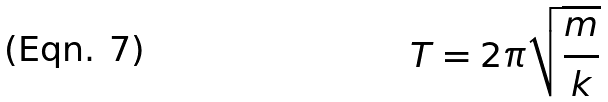Convert formula to latex. <formula><loc_0><loc_0><loc_500><loc_500>T = 2 \pi \sqrt { \frac { m } { k } }</formula> 